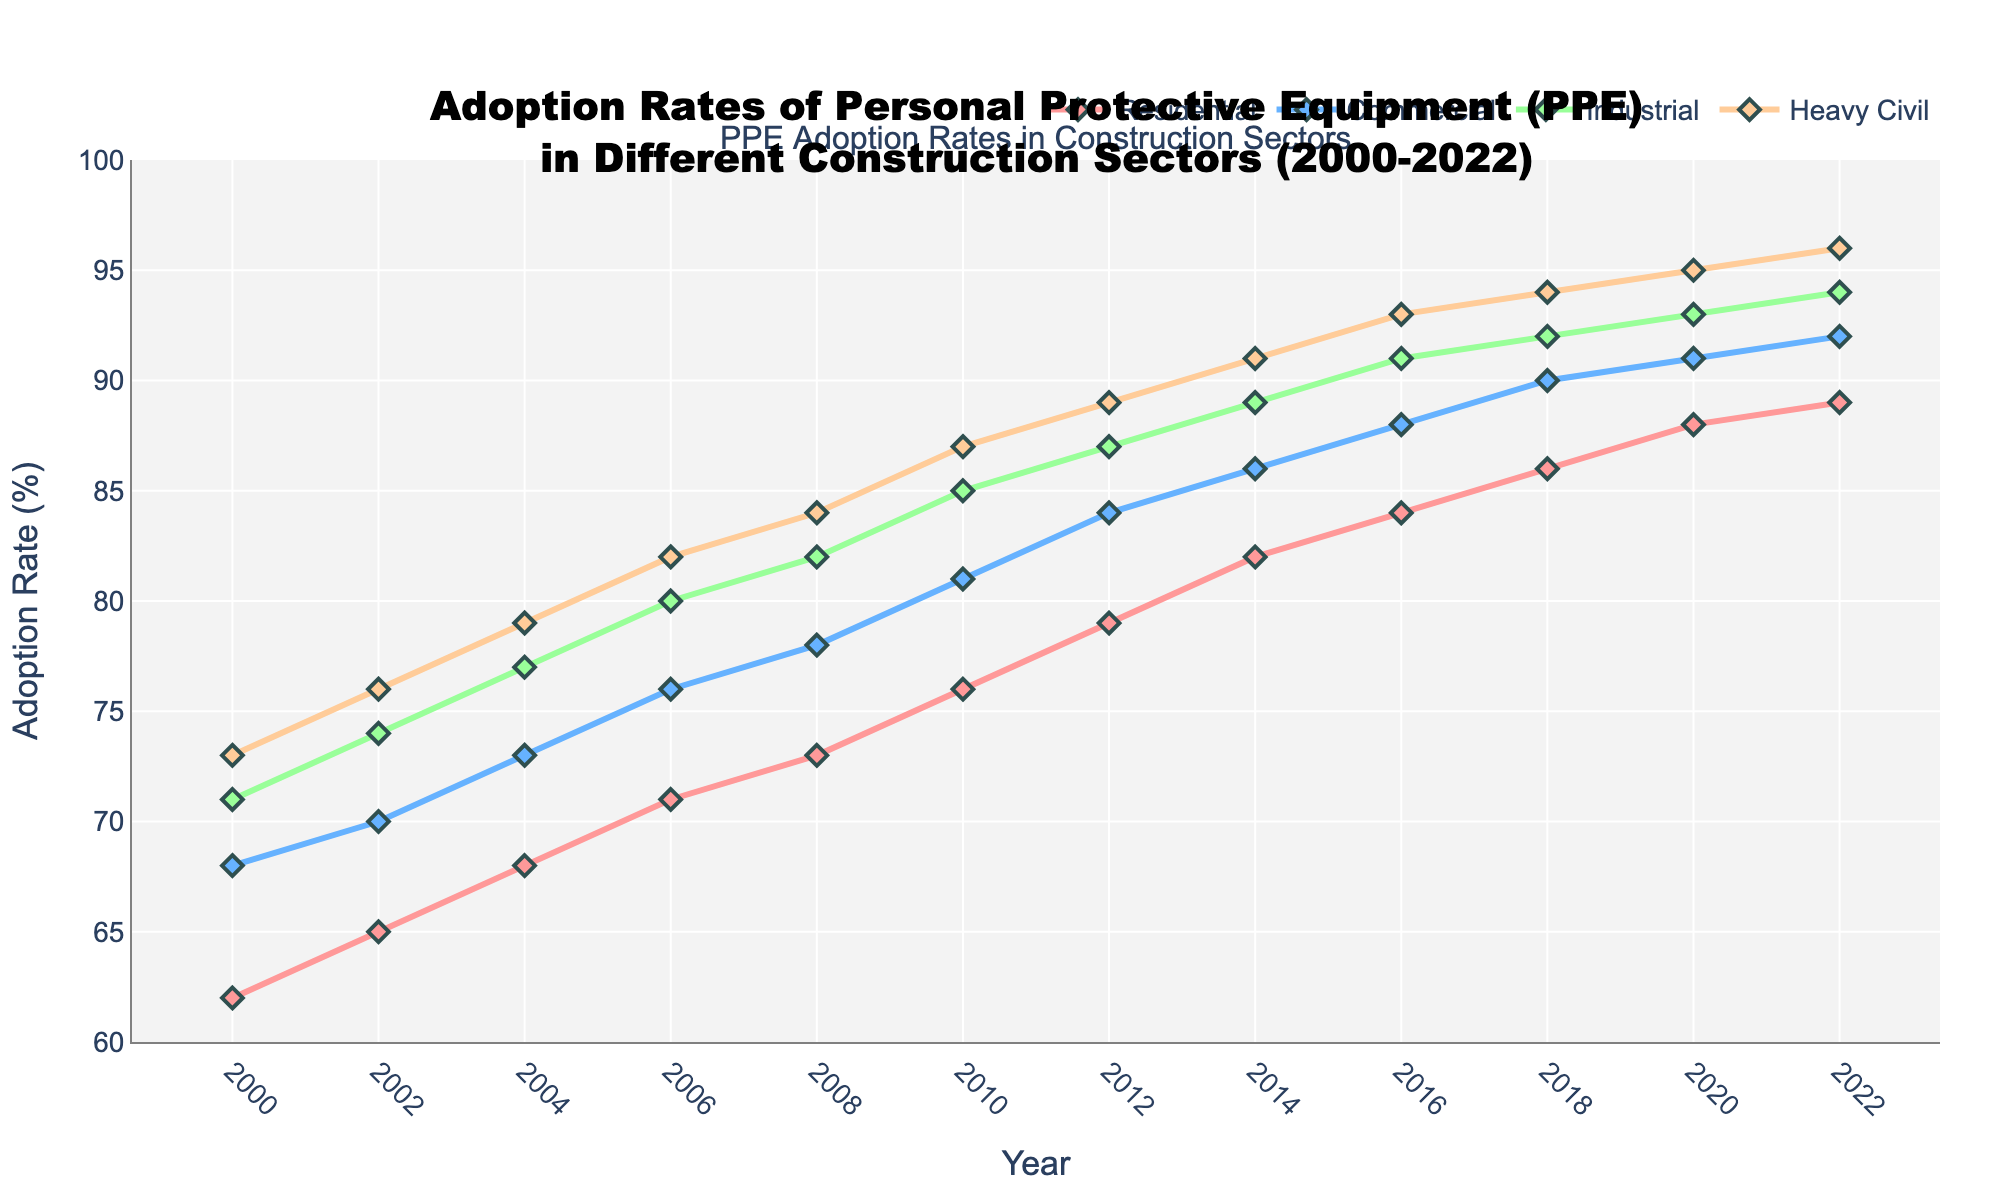What is the adoption rate of PPE in the Residential sector in 2008? To find the adoption rate in the Residential sector in 2008, locate the year 2008 on the x-axis and find the corresponding y-value for the Residential sector, which is represented by a specific colored line.
Answer: 73% Between which two years did the Heavy Civil sector see the largest increase in PPE adoption rates? Compare the year-over-year changes in the PPE adoption rate for the Heavy Civil sector by finding the differences in y-values between consecutive years. The largest increase can be identified by the greatest difference.
Answer: 2010 and 2012 Which sector had the lowest PPE adoption rate in 2000? Look at the y-values for all sectors in the year 2000. The sector with the smallest y-value has the lowest adoption rate.
Answer: Residential By how many percentage points did the adoption rate of PPE in the Commercial sector increase from 2000 to 2022? Subtract the adoption rate of the Commercial sector in 2000 from its adoption rate in 2022.
Answer: 24 percentage points What is the average PPE adoption rate for the Industrial sector over the entire period from 2000 to 2022? To find the average, add up the adoption rates for the Industrial sector from each year and divide by the number of years.
Answer: 84% Did any sector reach an adoption rate of 95% or higher? If so, which ones? Examine the highest adoption rates for each sector over the period and identify if any rate is 95% or higher.
Answer: Heavy Civil Which year showed the first convergence where all sectors had adoption rates above 80%? To find this, check each year starting from 2000 and see the y-values for all sectors being above 80%.
Answer: 2012 How does the trend in PPE adoption rates for the Commercial sector compare with the Industrial sector from 2000 to 2022? Observe the lines representing the Commercial and Industrial sectors over the years. Note whether they exhibit similar upward trends, plateaus, or varying rates of increase.
Answer: Both show an upward trend, with Industrial generally higher What is the total increase in PPE adoption rates across all sectors between 2000 and 2022? Calculate the increase for each sector (2022 value - 2000 value) and sum these increases.
Answer: 56 percentage points 